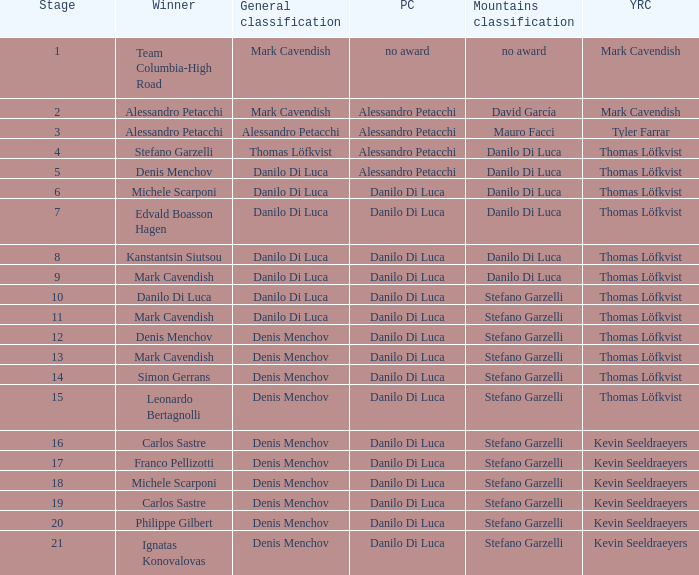When philippe gilbert is the winner who is the points classification? Danilo Di Luca. 